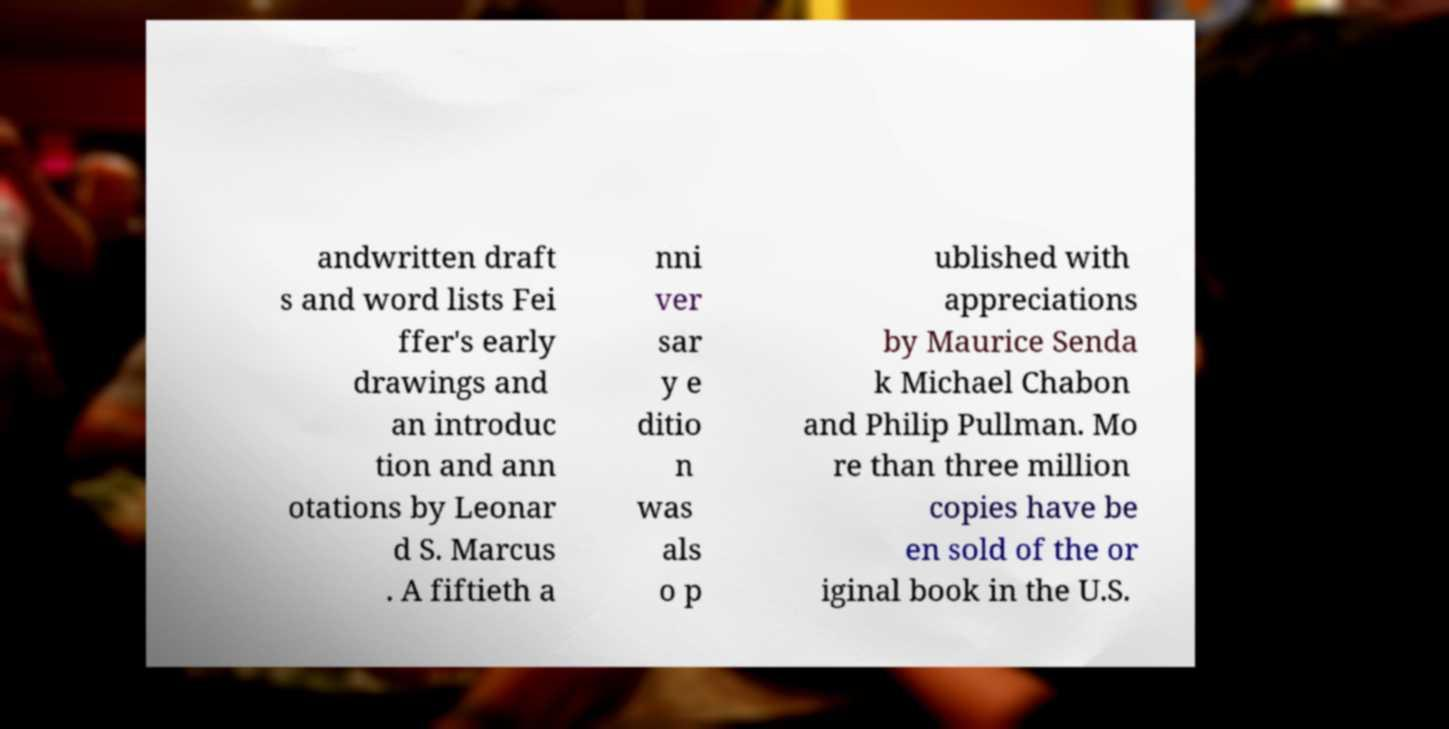Please read and relay the text visible in this image. What does it say? andwritten draft s and word lists Fei ffer's early drawings and an introduc tion and ann otations by Leonar d S. Marcus . A fiftieth a nni ver sar y e ditio n was als o p ublished with appreciations by Maurice Senda k Michael Chabon and Philip Pullman. Mo re than three million copies have be en sold of the or iginal book in the U.S. 